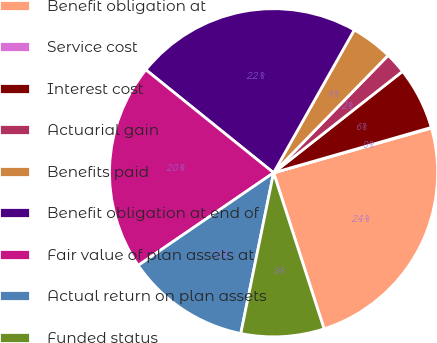<chart> <loc_0><loc_0><loc_500><loc_500><pie_chart><fcel>Benefit obligation at<fcel>Service cost<fcel>Interest cost<fcel>Actuarial gain<fcel>Benefits paid<fcel>Benefit obligation at end of<fcel>Fair value of plan assets at<fcel>Actual return on plan assets<fcel>Funded status<nl><fcel>24.41%<fcel>0.06%<fcel>6.15%<fcel>2.09%<fcel>4.12%<fcel>22.38%<fcel>20.35%<fcel>12.24%<fcel>8.18%<nl></chart> 